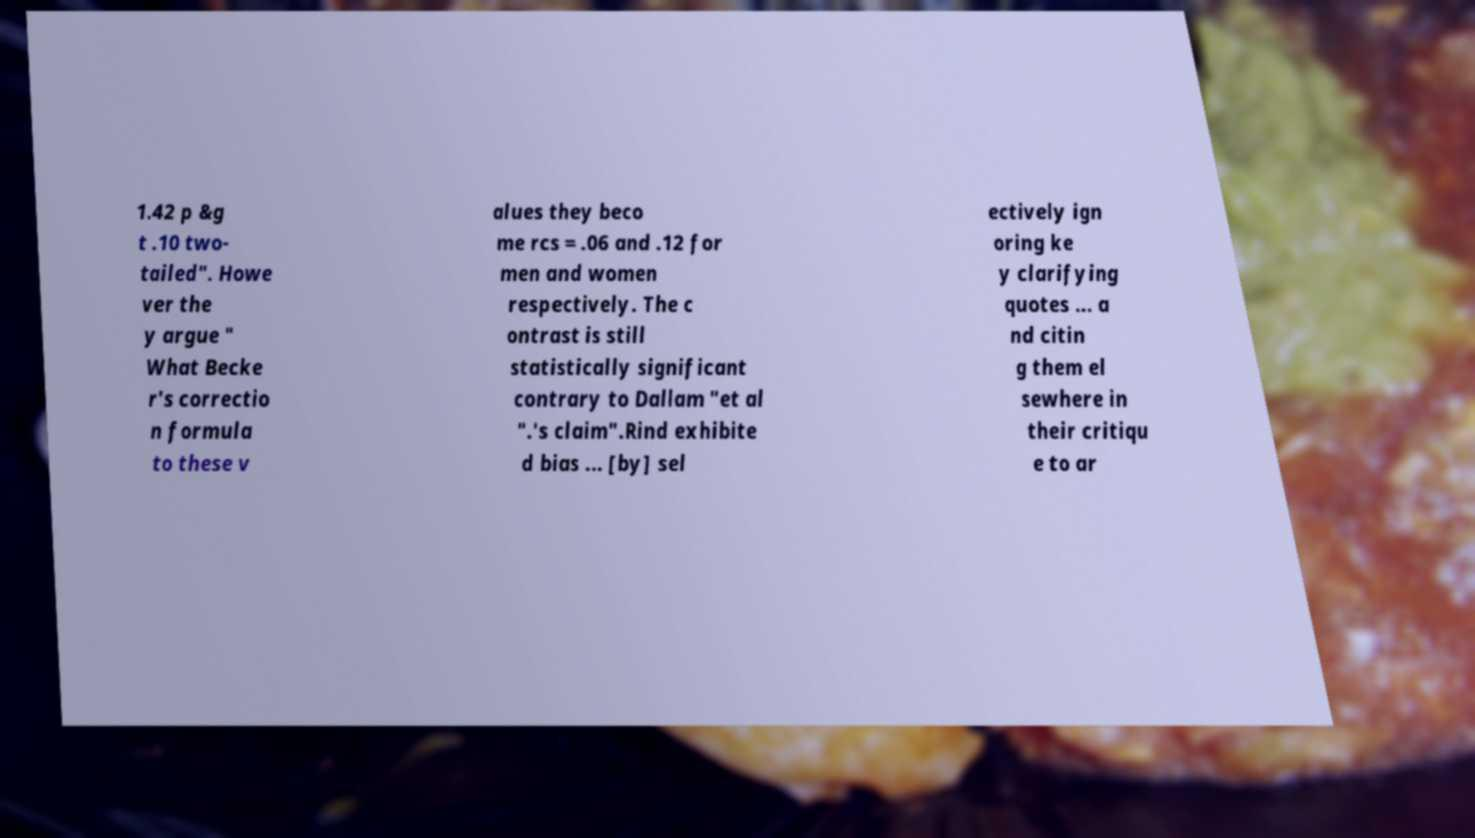Can you read and provide the text displayed in the image?This photo seems to have some interesting text. Can you extract and type it out for me? 1.42 p &g t .10 two- tailed". Howe ver the y argue " What Becke r's correctio n formula to these v alues they beco me rcs = .06 and .12 for men and women respectively. The c ontrast is still statistically significant contrary to Dallam "et al ".'s claim".Rind exhibite d bias ... [by] sel ectively ign oring ke y clarifying quotes ... a nd citin g them el sewhere in their critiqu e to ar 